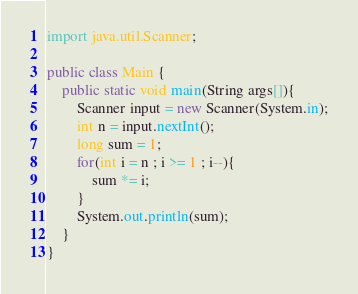<code> <loc_0><loc_0><loc_500><loc_500><_Java_>import java.util.Scanner;

public class Main {
    public static void main(String args[]){
        Scanner input = new Scanner(System.in);
        int n = input.nextInt();
        long sum = 1;
        for(int i = n ; i >= 1 ; i--){
        	sum *= i;
        }
        System.out.println(sum);
    }
}</code> 